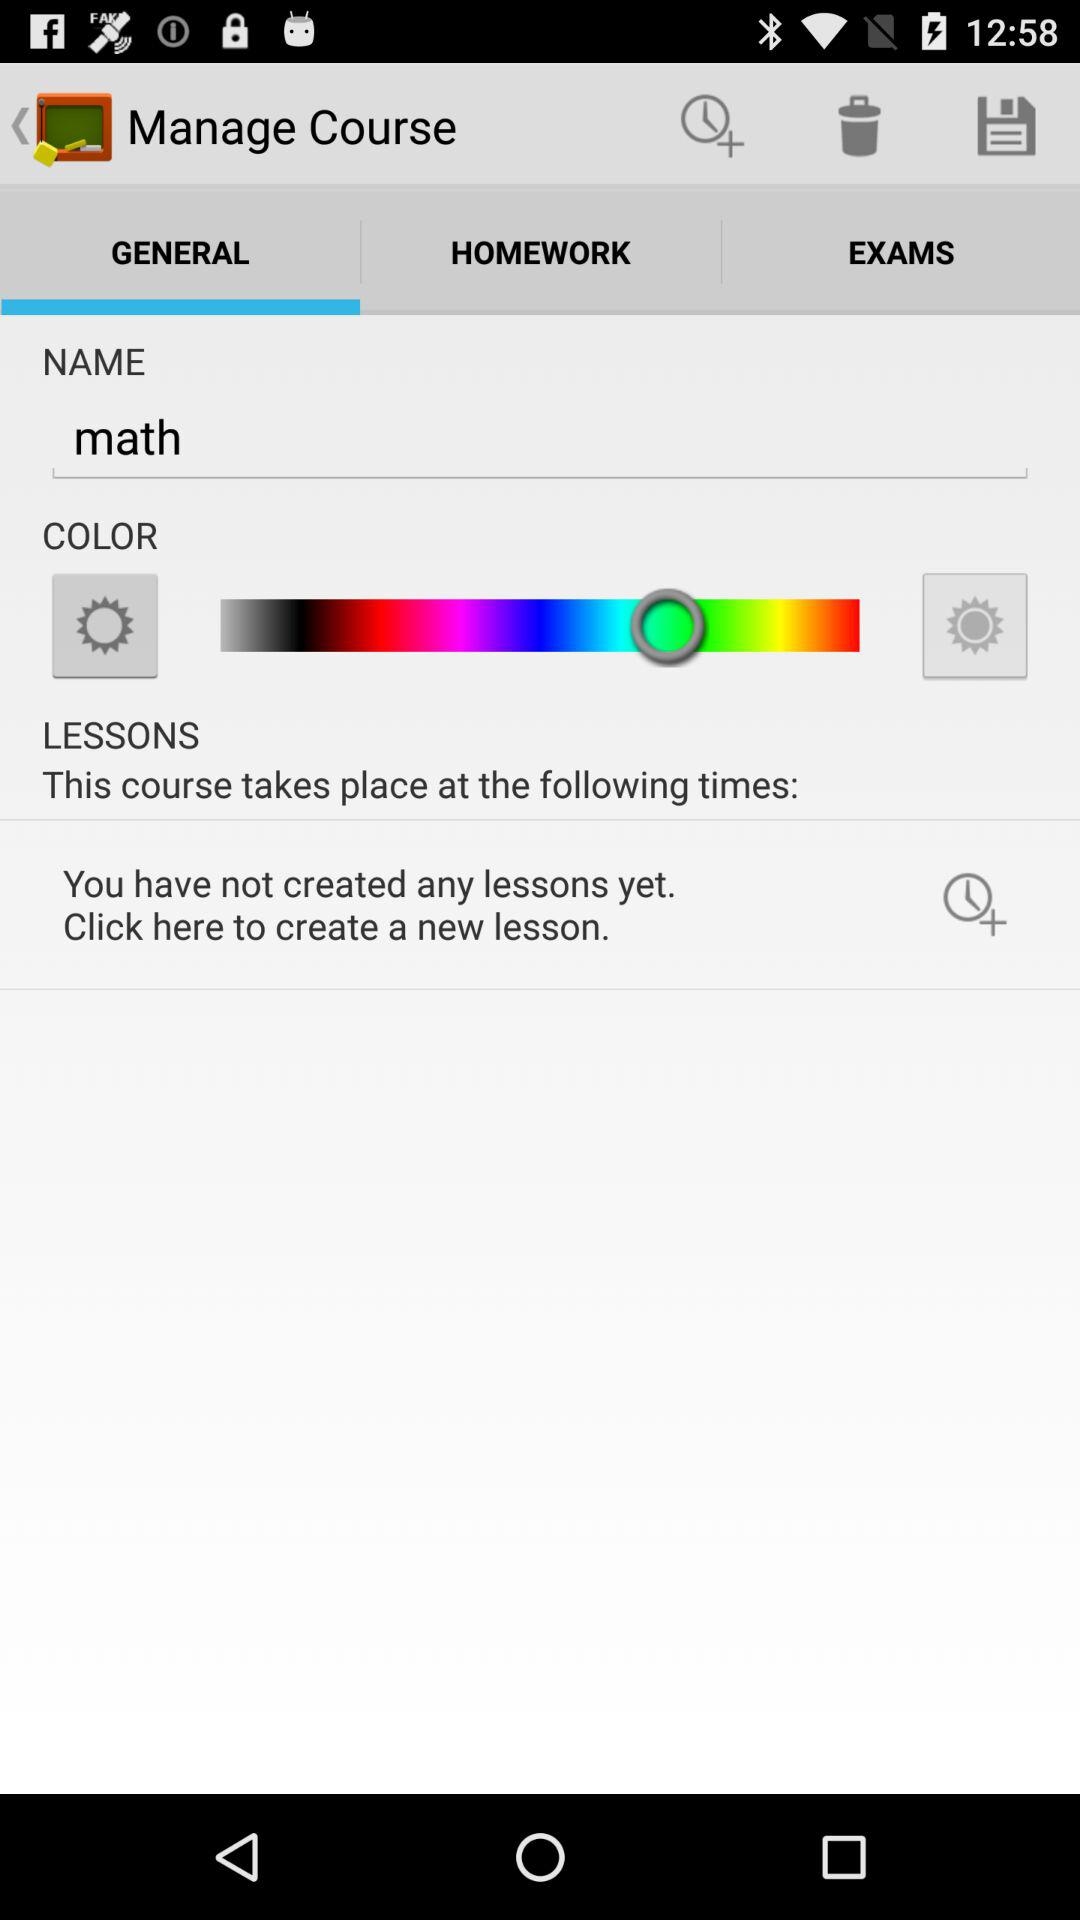What is the name? The name is Math. 